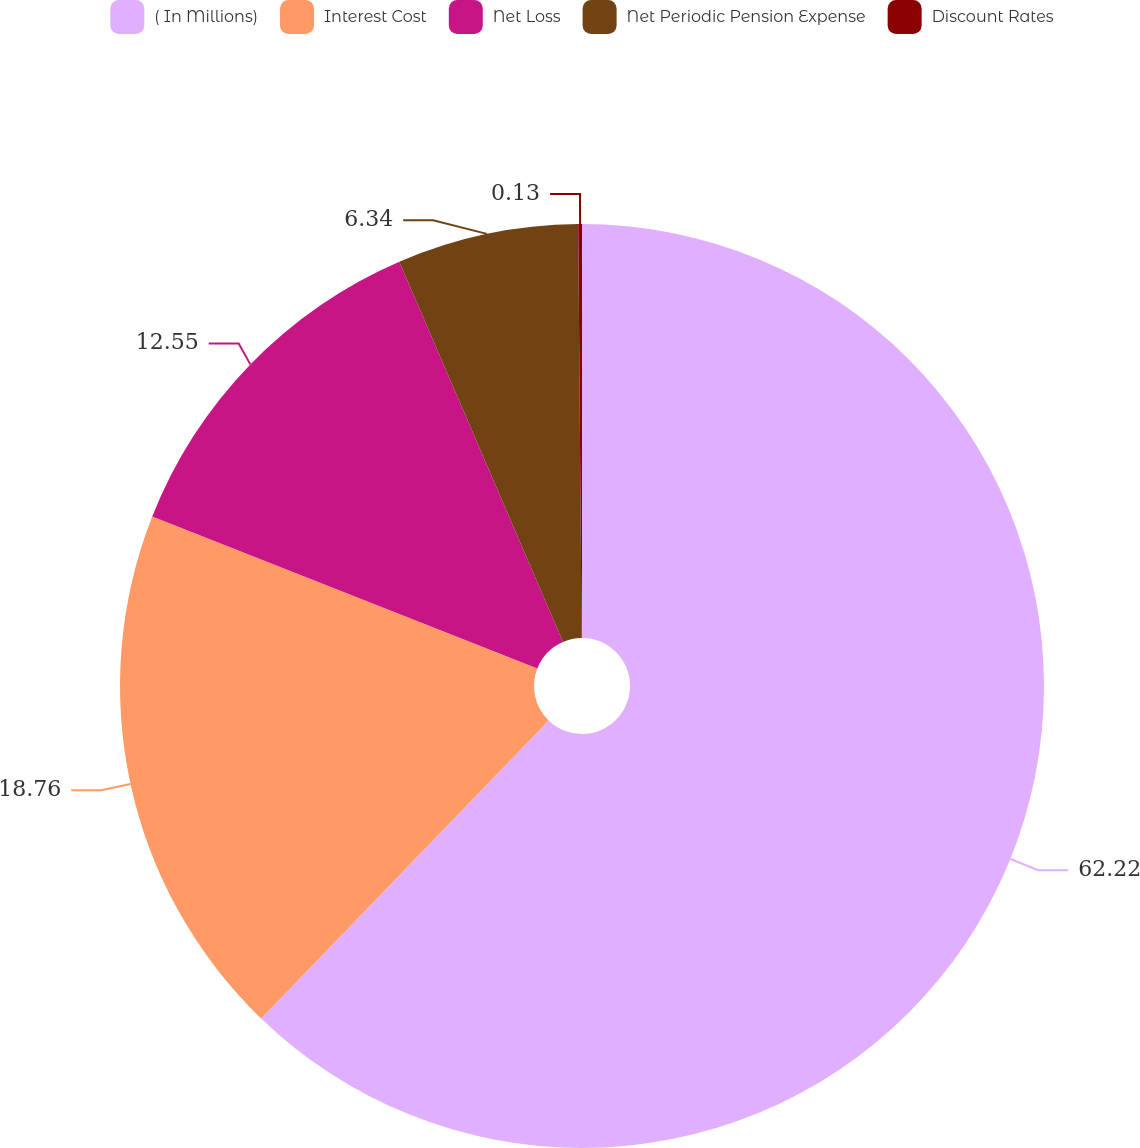Convert chart to OTSL. <chart><loc_0><loc_0><loc_500><loc_500><pie_chart><fcel>( In Millions)<fcel>Interest Cost<fcel>Net Loss<fcel>Net Periodic Pension Expense<fcel>Discount Rates<nl><fcel>62.22%<fcel>18.76%<fcel>12.55%<fcel>6.34%<fcel>0.13%<nl></chart> 